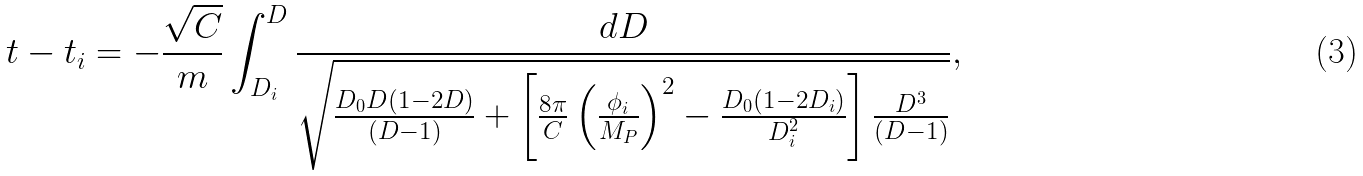<formula> <loc_0><loc_0><loc_500><loc_500>t - t _ { i } = - \frac { \sqrt { C } } { m } \int _ { D _ { i } } ^ { D } { \frac { d D } { \sqrt { \frac { D _ { 0 } D ( 1 - 2 D ) } { ( D - 1 ) } + \left [ \frac { 8 \pi } { C } \left ( \frac { \phi _ { i } } { M _ { P } } \right ) ^ { 2 } - \frac { D _ { 0 } ( 1 - 2 D _ { i } ) } { D _ { i } ^ { 2 } } \right ] \frac { D ^ { 3 } } { ( D - 1 ) } } } } ,</formula> 